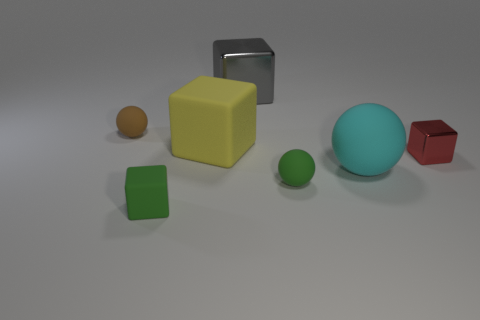Subtract all tiny balls. How many balls are left? 1 Add 1 gray metal things. How many objects exist? 8 Subtract all red blocks. How many blocks are left? 3 Subtract 0 purple cylinders. How many objects are left? 7 Subtract all cubes. How many objects are left? 3 Subtract all yellow spheres. Subtract all purple cylinders. How many spheres are left? 3 Subtract all small blue rubber balls. Subtract all rubber things. How many objects are left? 2 Add 2 small red metal objects. How many small red metal objects are left? 3 Add 2 small green matte things. How many small green matte things exist? 4 